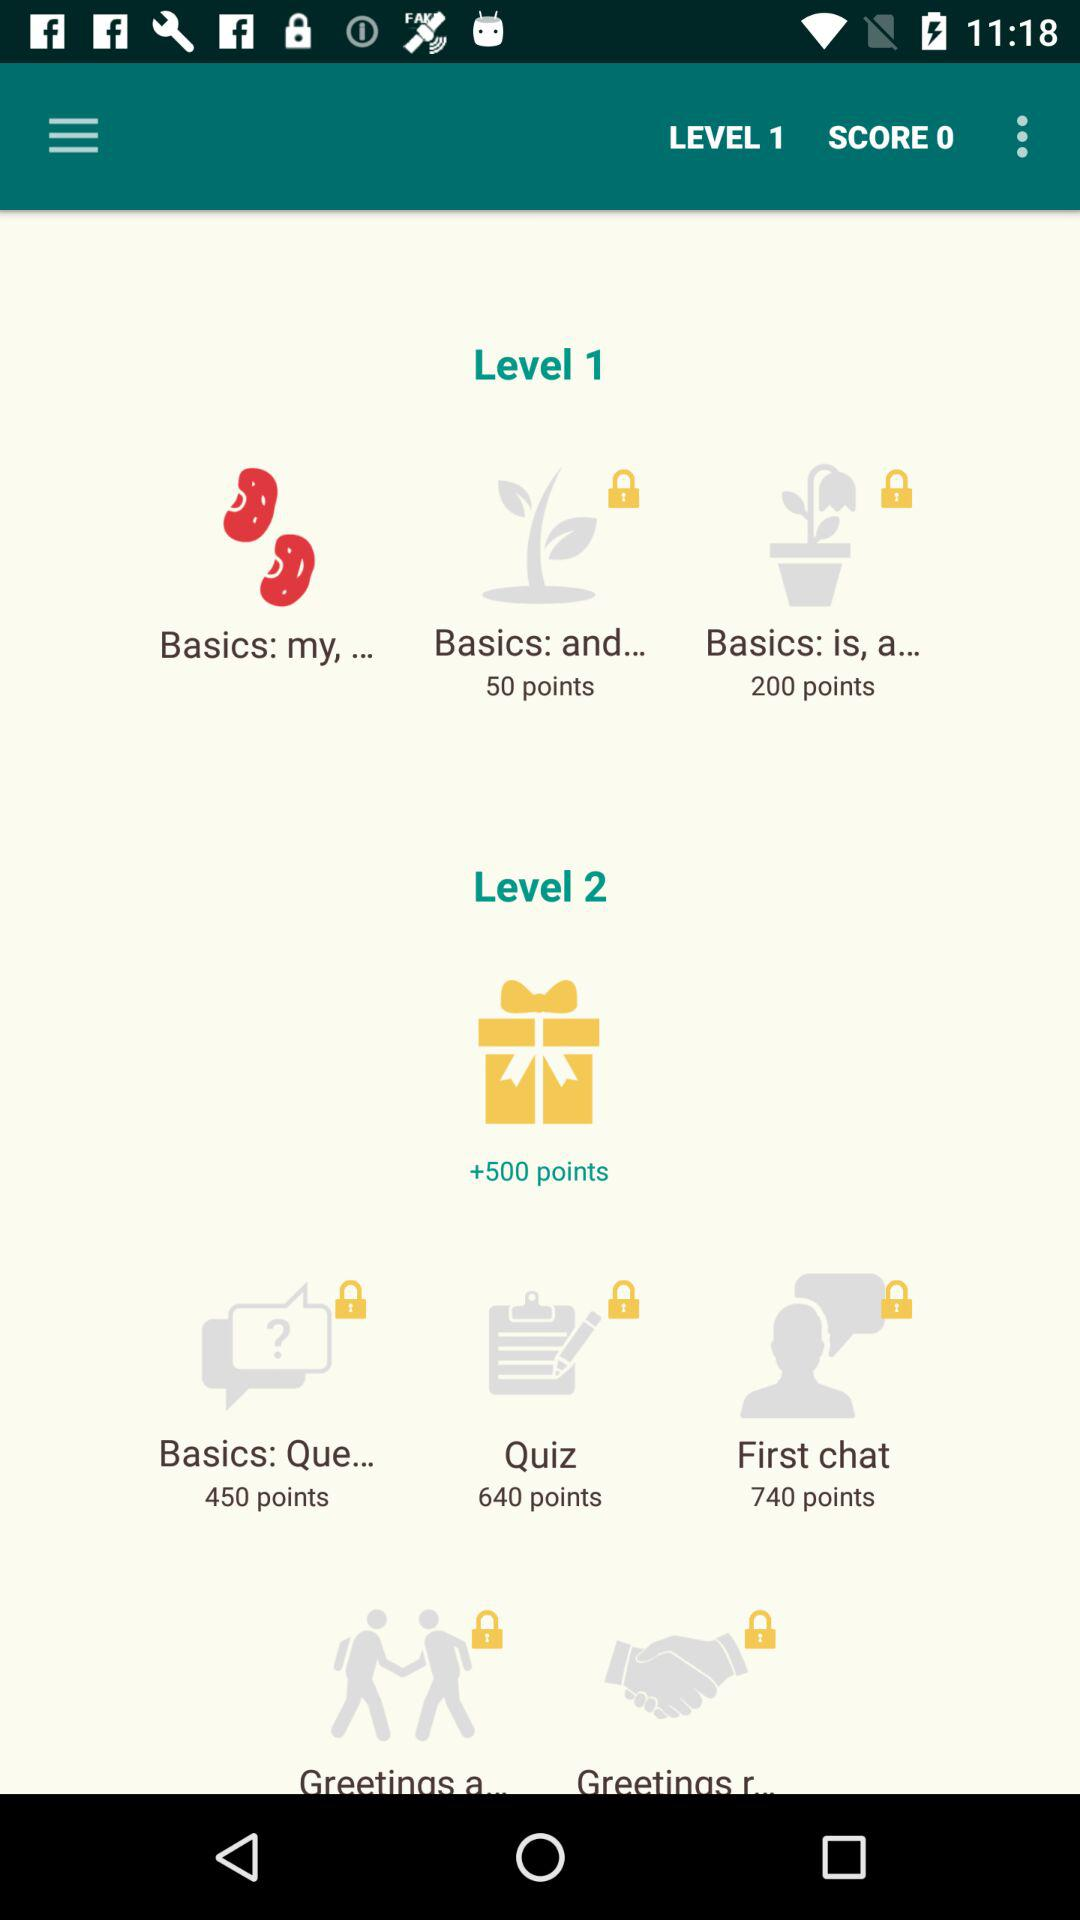How many "Basics: and..." points in level 1? There are 50 "Basics: and..." points in level 1. 